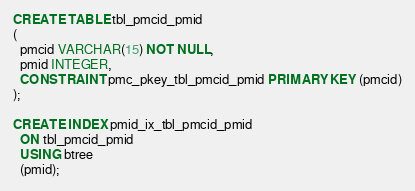<code> <loc_0><loc_0><loc_500><loc_500><_SQL_>CREATE TABLE tbl_pmcid_pmid
(
  pmcid VARCHAR(15) NOT NULL,
  pmid INTEGER,
  CONSTRAINT pmc_pkey_tbl_pmcid_pmid PRIMARY KEY (pmcid)
);

CREATE INDEX pmid_ix_tbl_pmcid_pmid
  ON tbl_pmcid_pmid
  USING btree
  (pmid);

</code> 